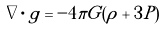<formula> <loc_0><loc_0><loc_500><loc_500>\nabla \cdot { g } = - 4 \pi G ( \rho + 3 P )</formula> 